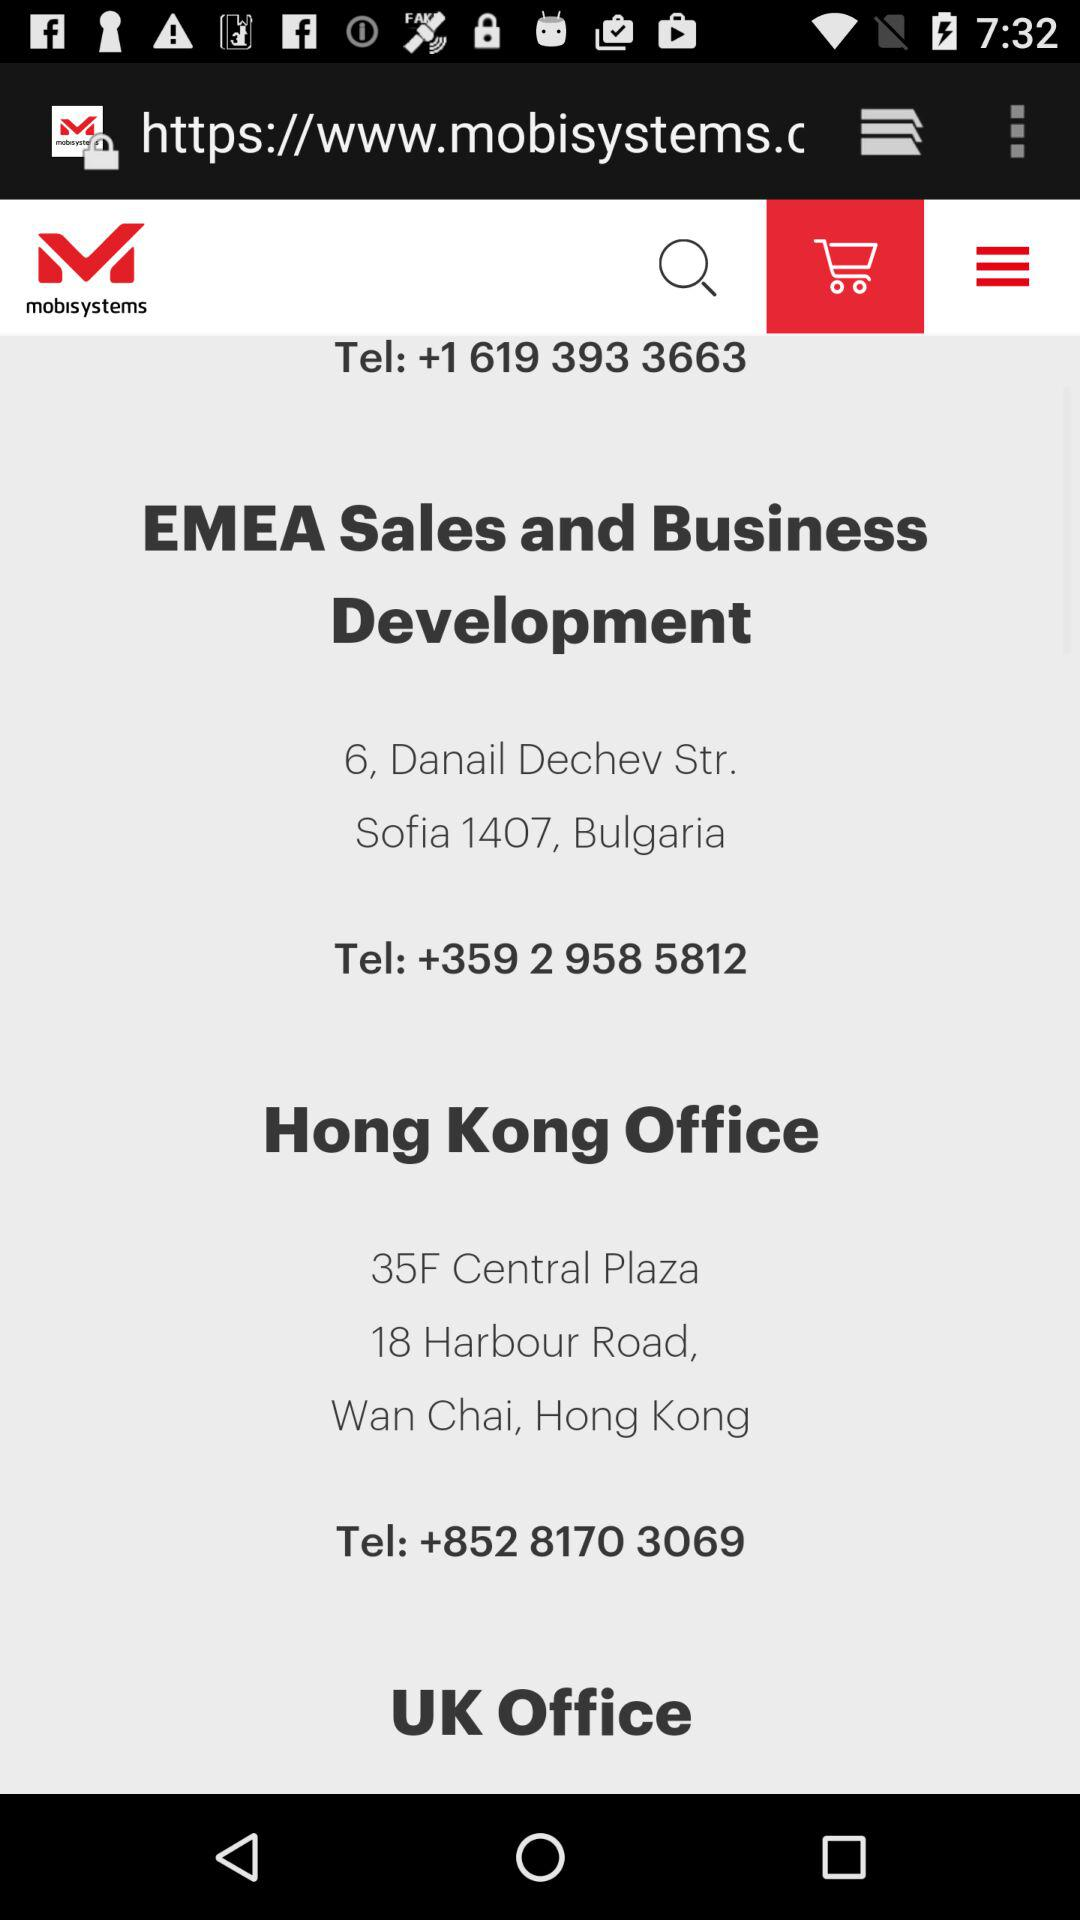What is the contact number of the "Hong Kong Office"? The contact number is +852 8170 3069. 